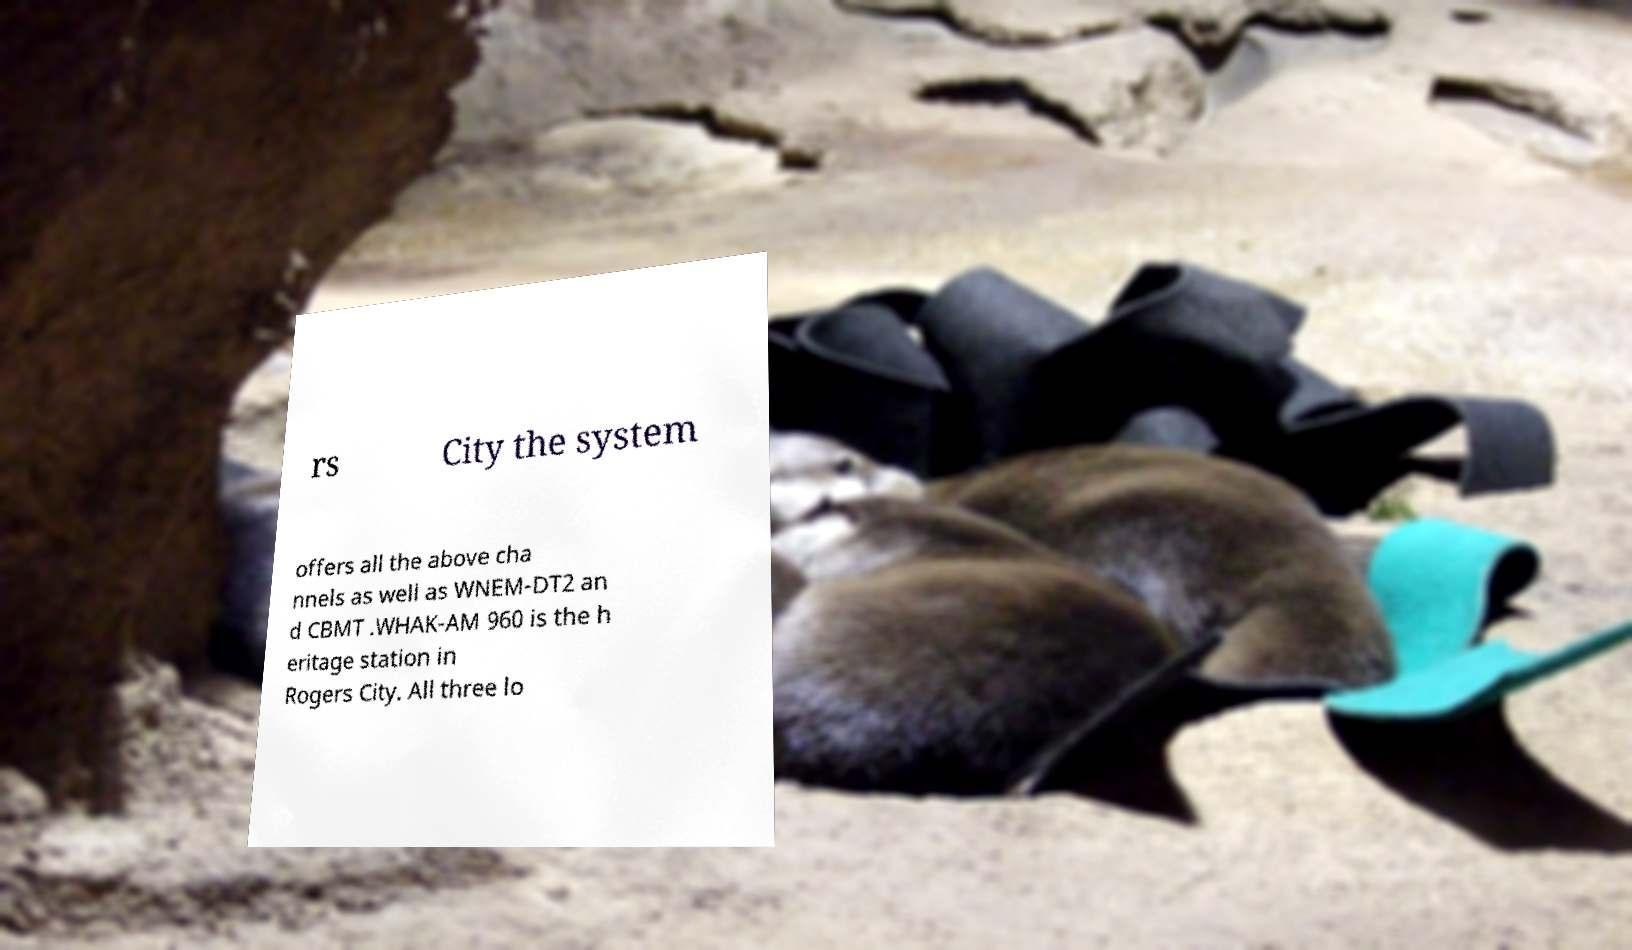Could you extract and type out the text from this image? rs City the system offers all the above cha nnels as well as WNEM-DT2 an d CBMT .WHAK-AM 960 is the h eritage station in Rogers City. All three lo 